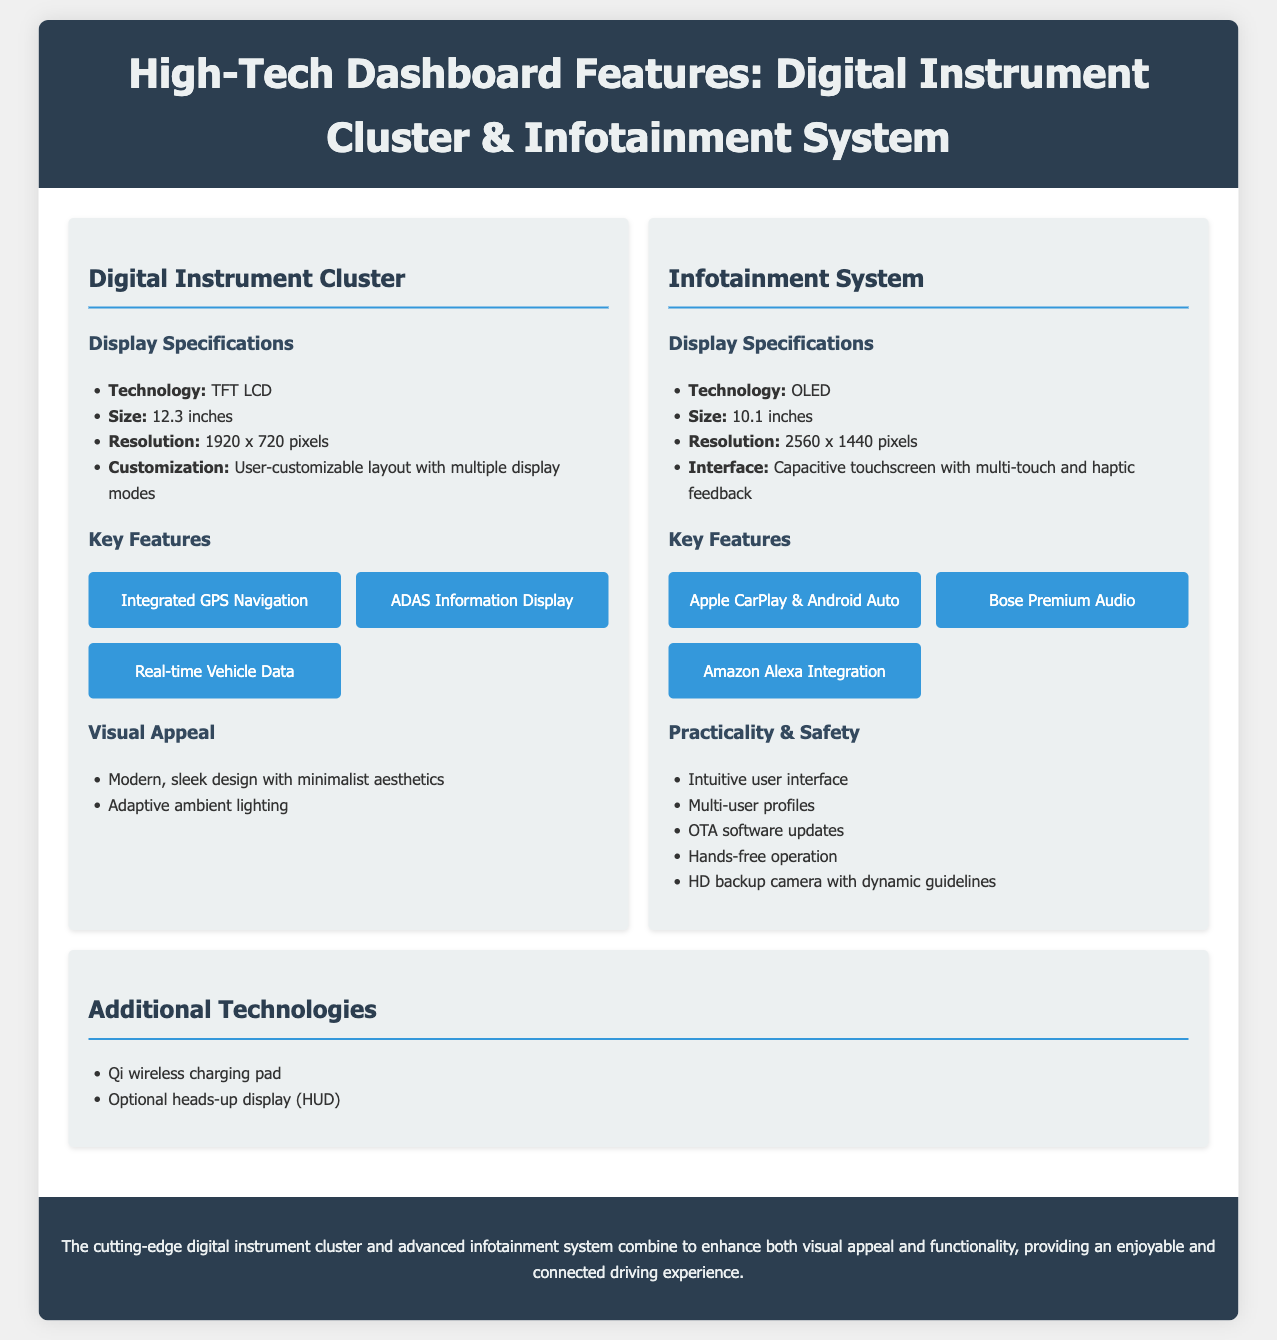What is the technology used in the Digital Instrument Cluster? The technology used in the Digital Instrument Cluster is specified in the document under the "Display Specifications" section.
Answer: TFT LCD What is the screen size of the Infotainment System? The screen size of the Infotainment System is listed in the "Display Specifications" section.
Answer: 10.1 inches How many custom display modes are available for the Digital Instrument Cluster? The document mentions that the layout is user-customizable, implying multiple modes are available, but does not specify an exact number.
Answer: Multiple What key feature integrates with smart assistants? The document lists specific key features of the Infotainment System which includes integration with smart assistants.
Answer: Amazon Alexa Integration What visual feature enhances the Digital Instrument Cluster's aesthetic? In the "Visual Appeal" section, one feature describes an enhancement to the visual aesthetics of the Digital Instrument Cluster.
Answer: Adaptive ambient lighting What audio system is included in the Infotainment System? The document specifically names the audio system featured in the Infotainment System's key features section.
Answer: Bose Premium Audio What safety feature is mentioned in the Infotainment System? The “Practicality & Safety” section of the document lists features related to safety in the Infotainment System.
Answer: HD backup camera with dynamic guidelines What type of wireless charging is available? The additional technologies section specifies the type of wireless charging feature included in the document.
Answer: Qi wireless charging pad What is the resolution of the Digital Instrument Cluster? The resolution of the Digital Instrument Cluster is a specific detail provided under the "Display Specifications" section.
Answer: 1920 x 720 pixels 